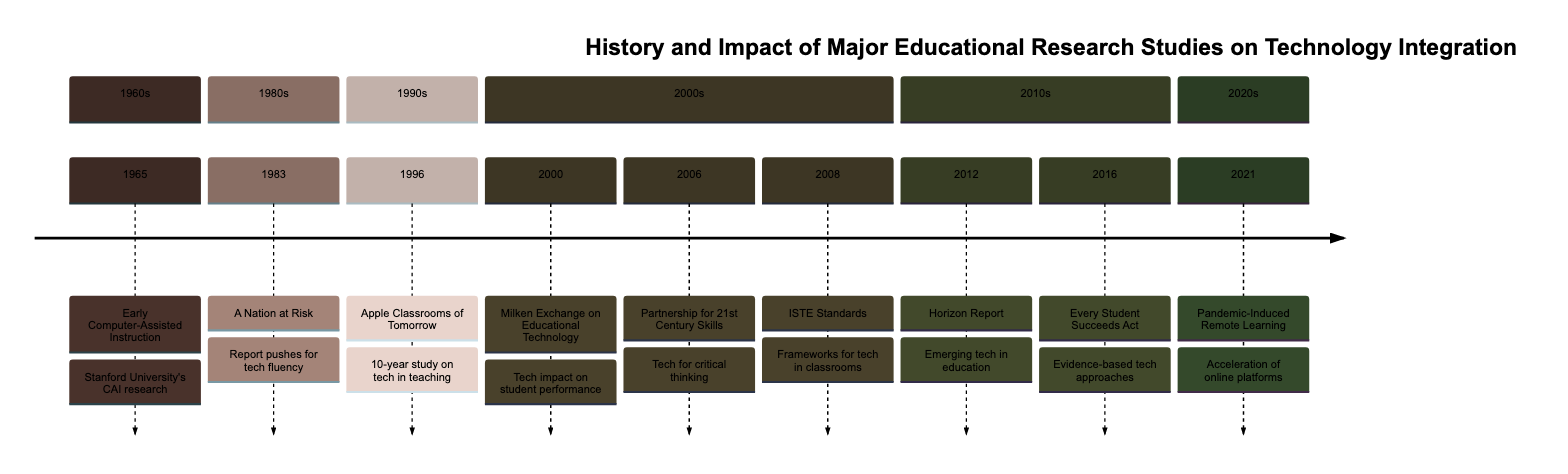What year did Early Computer-Assisted Instruction start? The diagram indicates that Early Computer-Assisted Instruction began in the year 1965.
Answer: 1965 What event is associated with the year 2000? According to the diagram, the event associated with the year 2000 is "The Milken Exchange on Educational Technology."
Answer: The Milken Exchange on Educational Technology What is the primary focus of the report "A Nation at Risk"? The diagram states that "A Nation at Risk" emphasizes the need for technological fluency in education.
Answer: Technological fluency What year's research emphasizes the integration of technology for critical thinking? The diagram indicates that the year 2006 focuses on "The Partnership for 21st Century Skills," which emphasizes technology for critical thinking.
Answer: 2006 Which study concluded in 1996? In the diagram, it shows that "The Apple Classrooms of Tomorrow (ACOT)" study concluded in 1996.
Answer: The Apple Classrooms of Tomorrow What significant change in educational policy occurred in 2016? The diagram mentions that in 2016, the Every Student Succeeds Act (ESSA) replaced No Child Left Behind, emphasizing evidence-based approaches.
Answer: Every Student Succeeds Act How many events are listed in the 2000s? The diagram shows three events listed under the 2000s section, including 2000, 2006, and 2008.
Answer: Three What does the 2012 Horizon Report discuss? The diagram states that the 2012 Horizon Report discusses emerging technologies likely to impact education over the next five years.
Answer: Emerging technologies What prompted new research on remote education in 2021? The diagram highlights that the COVID-19 pandemic accelerated the integration of online learning platforms, prompting new research on remote education.
Answer: COVID-19 pandemic 